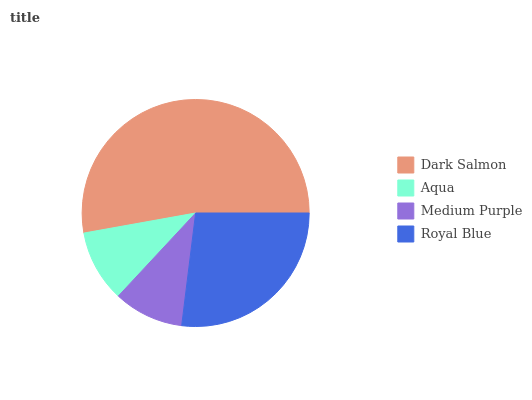Is Medium Purple the minimum?
Answer yes or no. Yes. Is Dark Salmon the maximum?
Answer yes or no. Yes. Is Aqua the minimum?
Answer yes or no. No. Is Aqua the maximum?
Answer yes or no. No. Is Dark Salmon greater than Aqua?
Answer yes or no. Yes. Is Aqua less than Dark Salmon?
Answer yes or no. Yes. Is Aqua greater than Dark Salmon?
Answer yes or no. No. Is Dark Salmon less than Aqua?
Answer yes or no. No. Is Royal Blue the high median?
Answer yes or no. Yes. Is Aqua the low median?
Answer yes or no. Yes. Is Aqua the high median?
Answer yes or no. No. Is Royal Blue the low median?
Answer yes or no. No. 